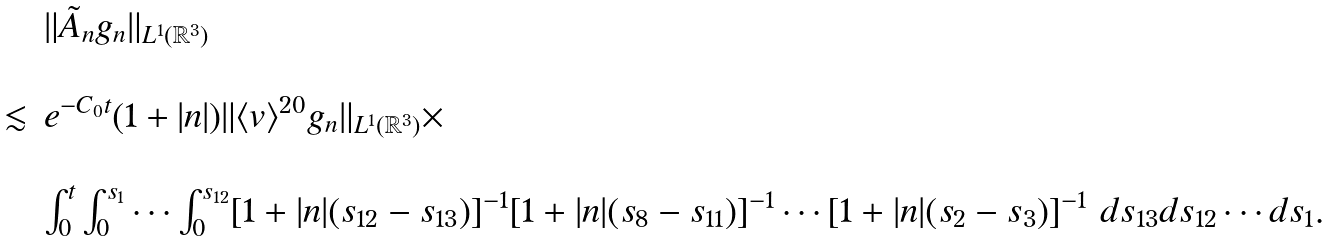Convert formula to latex. <formula><loc_0><loc_0><loc_500><loc_500>\begin{array} { l l l } & & \| \tilde { A } _ { n } g _ { n } \| _ { L ^ { 1 } ( \mathbb { R } ^ { 3 } ) } \\ & & \\ & \lesssim & e ^ { - C _ { 0 } t } ( 1 + | { n } | ) \| \langle v \rangle ^ { 2 0 } g _ { n } \| _ { L ^ { 1 } ( \mathbb { R } ^ { 3 } ) } \times \\ & & \\ & & \int _ { 0 } ^ { t } \int _ { 0 } ^ { s _ { 1 } } \cdots \int _ { 0 } ^ { s _ { 1 2 } } [ 1 + | { n } | ( s _ { 1 2 } - s _ { 1 3 } ) ] ^ { - 1 } [ 1 + | { n } | ( s _ { 8 } - s _ { 1 1 } ) ] ^ { - 1 } \cdots [ 1 + | { n } | ( s _ { 2 } - s _ { 3 } ) ] ^ { - 1 } \ d s _ { 1 3 } d s _ { 1 2 } \cdots d s _ { 1 } . \end{array}</formula> 